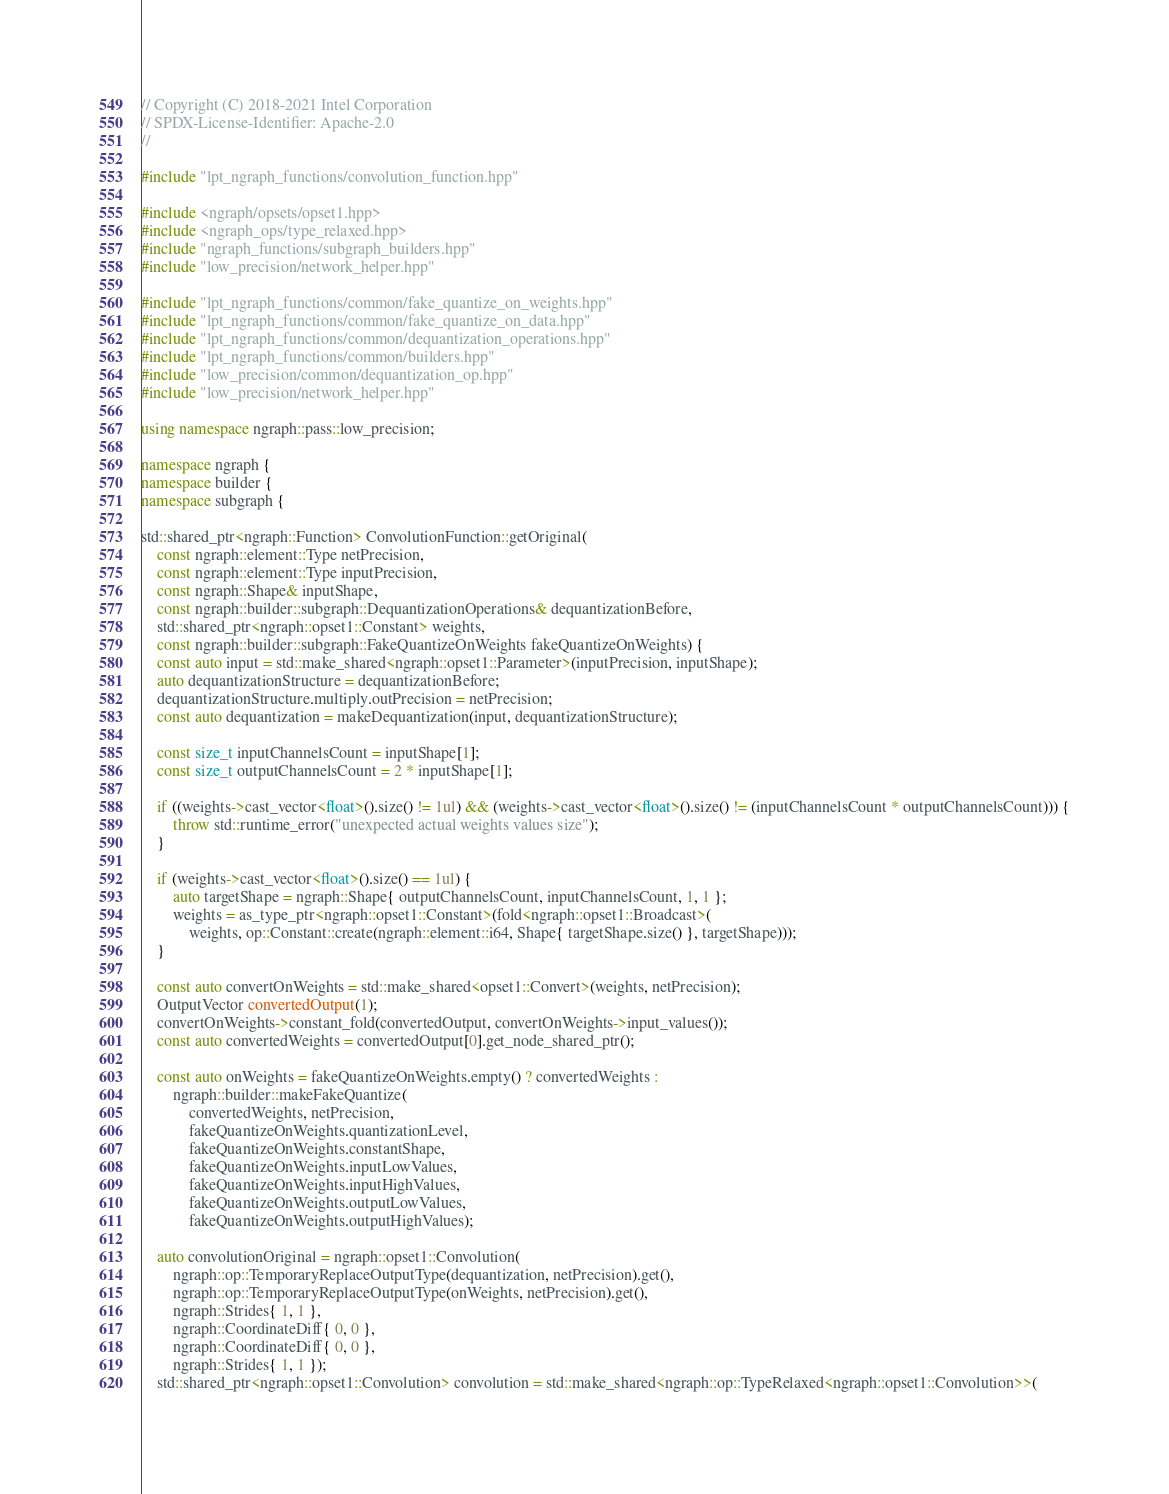Convert code to text. <code><loc_0><loc_0><loc_500><loc_500><_C++_>// Copyright (C) 2018-2021 Intel Corporation
// SPDX-License-Identifier: Apache-2.0
//

#include "lpt_ngraph_functions/convolution_function.hpp"

#include <ngraph/opsets/opset1.hpp>
#include <ngraph_ops/type_relaxed.hpp>
#include "ngraph_functions/subgraph_builders.hpp"
#include "low_precision/network_helper.hpp"

#include "lpt_ngraph_functions/common/fake_quantize_on_weights.hpp"
#include "lpt_ngraph_functions/common/fake_quantize_on_data.hpp"
#include "lpt_ngraph_functions/common/dequantization_operations.hpp"
#include "lpt_ngraph_functions/common/builders.hpp"
#include "low_precision/common/dequantization_op.hpp"
#include "low_precision/network_helper.hpp"

using namespace ngraph::pass::low_precision;

namespace ngraph {
namespace builder {
namespace subgraph {

std::shared_ptr<ngraph::Function> ConvolutionFunction::getOriginal(
    const ngraph::element::Type netPrecision,
    const ngraph::element::Type inputPrecision,
    const ngraph::Shape& inputShape,
    const ngraph::builder::subgraph::DequantizationOperations& dequantizationBefore,
    std::shared_ptr<ngraph::opset1::Constant> weights,
    const ngraph::builder::subgraph::FakeQuantizeOnWeights fakeQuantizeOnWeights) {
    const auto input = std::make_shared<ngraph::opset1::Parameter>(inputPrecision, inputShape);
    auto dequantizationStructure = dequantizationBefore;
    dequantizationStructure.multiply.outPrecision = netPrecision;
    const auto dequantization = makeDequantization(input, dequantizationStructure);

    const size_t inputChannelsCount = inputShape[1];
    const size_t outputChannelsCount = 2 * inputShape[1];

    if ((weights->cast_vector<float>().size() != 1ul) && (weights->cast_vector<float>().size() != (inputChannelsCount * outputChannelsCount))) {
        throw std::runtime_error("unexpected actual weights values size");
    }

    if (weights->cast_vector<float>().size() == 1ul) {
        auto targetShape = ngraph::Shape{ outputChannelsCount, inputChannelsCount, 1, 1 };
        weights = as_type_ptr<ngraph::opset1::Constant>(fold<ngraph::opset1::Broadcast>(
            weights, op::Constant::create(ngraph::element::i64, Shape{ targetShape.size() }, targetShape)));
    }

    const auto convertOnWeights = std::make_shared<opset1::Convert>(weights, netPrecision);
    OutputVector convertedOutput(1);
    convertOnWeights->constant_fold(convertedOutput, convertOnWeights->input_values());
    const auto convertedWeights = convertedOutput[0].get_node_shared_ptr();

    const auto onWeights = fakeQuantizeOnWeights.empty() ? convertedWeights :
        ngraph::builder::makeFakeQuantize(
            convertedWeights, netPrecision,
            fakeQuantizeOnWeights.quantizationLevel,
            fakeQuantizeOnWeights.constantShape,
            fakeQuantizeOnWeights.inputLowValues,
            fakeQuantizeOnWeights.inputHighValues,
            fakeQuantizeOnWeights.outputLowValues,
            fakeQuantizeOnWeights.outputHighValues);

    auto convolutionOriginal = ngraph::opset1::Convolution(
        ngraph::op::TemporaryReplaceOutputType(dequantization, netPrecision).get(),
        ngraph::op::TemporaryReplaceOutputType(onWeights, netPrecision).get(),
        ngraph::Strides{ 1, 1 },
        ngraph::CoordinateDiff{ 0, 0 },
        ngraph::CoordinateDiff{ 0, 0 },
        ngraph::Strides{ 1, 1 });
    std::shared_ptr<ngraph::opset1::Convolution> convolution = std::make_shared<ngraph::op::TypeRelaxed<ngraph::opset1::Convolution>>(</code> 